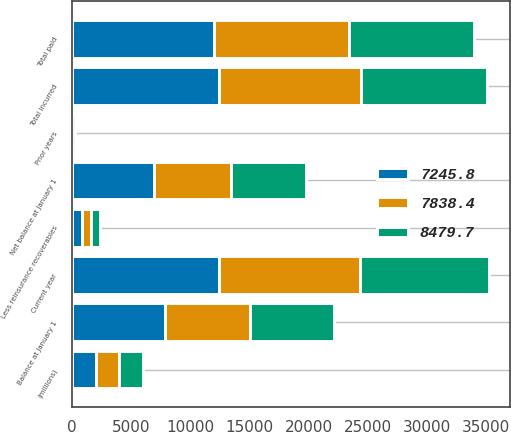Convert chart to OTSL. <chart><loc_0><loc_0><loc_500><loc_500><stacked_bar_chart><ecel><fcel>(millions)<fcel>Balance at January 1<fcel>Less reinsurance recoverables<fcel>Net balance at January 1<fcel>Current year<fcel>Prior years<fcel>Total incurred<fcel>Total paid<nl><fcel>7245.8<fcel>2013<fcel>7838.4<fcel>862.1<fcel>6976.3<fcel>12427.3<fcel>45.1<fcel>12472.4<fcel>12014.9<nl><fcel>7838.4<fcel>2012<fcel>7245.8<fcel>785.7<fcel>6460.1<fcel>11926<fcel>22<fcel>11948<fcel>11431.8<nl><fcel>8479.7<fcel>2011<fcel>7071<fcel>704.1<fcel>6366.9<fcel>10876.8<fcel>242<fcel>10634.8<fcel>10541.6<nl></chart> 